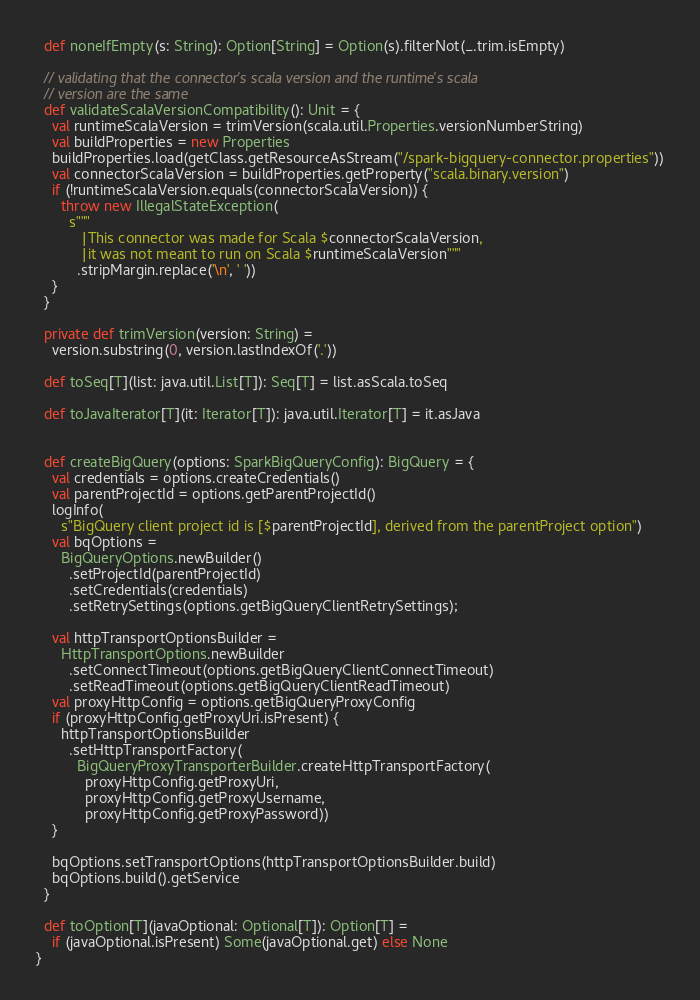Convert code to text. <code><loc_0><loc_0><loc_500><loc_500><_Scala_>  def noneIfEmpty(s: String): Option[String] = Option(s).filterNot(_.trim.isEmpty)

  // validating that the connector's scala version and the runtime's scala
  // version are the same
  def validateScalaVersionCompatibility(): Unit = {
    val runtimeScalaVersion = trimVersion(scala.util.Properties.versionNumberString)
    val buildProperties = new Properties
    buildProperties.load(getClass.getResourceAsStream("/spark-bigquery-connector.properties"))
    val connectorScalaVersion = buildProperties.getProperty("scala.binary.version")
    if (!runtimeScalaVersion.equals(connectorScalaVersion)) {
      throw new IllegalStateException(
        s"""
           |This connector was made for Scala $connectorScalaVersion,
           |it was not meant to run on Scala $runtimeScalaVersion"""
          .stripMargin.replace('\n', ' '))
    }
  }

  private def trimVersion(version: String) =
    version.substring(0, version.lastIndexOf('.'))

  def toSeq[T](list: java.util.List[T]): Seq[T] = list.asScala.toSeq

  def toJavaIterator[T](it: Iterator[T]): java.util.Iterator[T] = it.asJava


  def createBigQuery(options: SparkBigQueryConfig): BigQuery = {
    val credentials = options.createCredentials()
    val parentProjectId = options.getParentProjectId()
    logInfo(
      s"BigQuery client project id is [$parentProjectId], derived from the parentProject option")
    val bqOptions =
      BigQueryOptions.newBuilder()
        .setProjectId(parentProjectId)
        .setCredentials(credentials)
        .setRetrySettings(options.getBigQueryClientRetrySettings);

    val httpTransportOptionsBuilder =
      HttpTransportOptions.newBuilder
        .setConnectTimeout(options.getBigQueryClientConnectTimeout)
        .setReadTimeout(options.getBigQueryClientReadTimeout)
    val proxyHttpConfig = options.getBigQueryProxyConfig
    if (proxyHttpConfig.getProxyUri.isPresent) {
      httpTransportOptionsBuilder
        .setHttpTransportFactory(
          BigQueryProxyTransporterBuilder.createHttpTransportFactory(
            proxyHttpConfig.getProxyUri,
            proxyHttpConfig.getProxyUsername,
            proxyHttpConfig.getProxyPassword))
    }

    bqOptions.setTransportOptions(httpTransportOptionsBuilder.build)
    bqOptions.build().getService
  }

  def toOption[T](javaOptional: Optional[T]): Option[T] =
    if (javaOptional.isPresent) Some(javaOptional.get) else None
}
</code> 